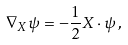<formula> <loc_0><loc_0><loc_500><loc_500>\nabla _ { X } \psi = - \frac { 1 } { 2 } X \cdot \psi \, ,</formula> 